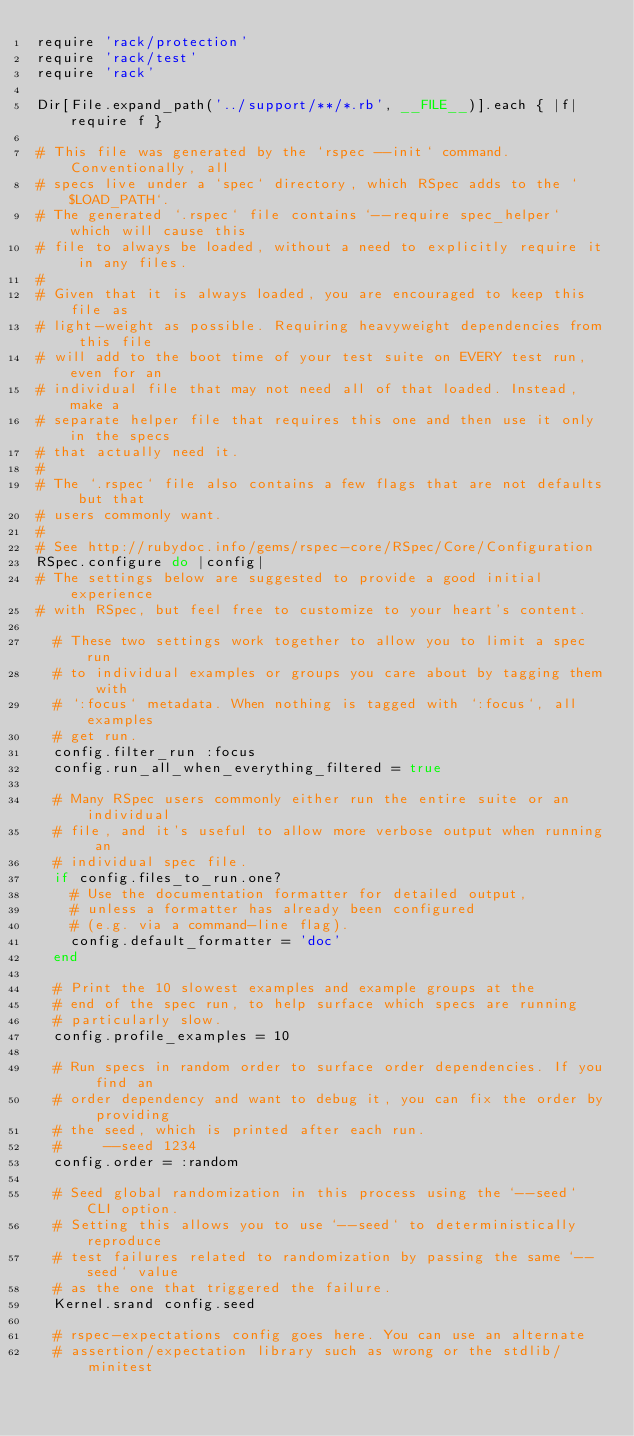Convert code to text. <code><loc_0><loc_0><loc_500><loc_500><_Ruby_>require 'rack/protection'
require 'rack/test'
require 'rack'

Dir[File.expand_path('../support/**/*.rb', __FILE__)].each { |f| require f }

# This file was generated by the `rspec --init` command. Conventionally, all
# specs live under a `spec` directory, which RSpec adds to the `$LOAD_PATH`.
# The generated `.rspec` file contains `--require spec_helper` which will cause this
# file to always be loaded, without a need to explicitly require it in any files.
#
# Given that it is always loaded, you are encouraged to keep this file as
# light-weight as possible. Requiring heavyweight dependencies from this file
# will add to the boot time of your test suite on EVERY test run, even for an
# individual file that may not need all of that loaded. Instead, make a
# separate helper file that requires this one and then use it only in the specs
# that actually need it.
#
# The `.rspec` file also contains a few flags that are not defaults but that
# users commonly want.
#
# See http://rubydoc.info/gems/rspec-core/RSpec/Core/Configuration
RSpec.configure do |config|
# The settings below are suggested to provide a good initial experience
# with RSpec, but feel free to customize to your heart's content.

  # These two settings work together to allow you to limit a spec run
  # to individual examples or groups you care about by tagging them with
  # `:focus` metadata. When nothing is tagged with `:focus`, all examples
  # get run.
  config.filter_run :focus
  config.run_all_when_everything_filtered = true

  # Many RSpec users commonly either run the entire suite or an individual
  # file, and it's useful to allow more verbose output when running an
  # individual spec file.
  if config.files_to_run.one?
    # Use the documentation formatter for detailed output,
    # unless a formatter has already been configured
    # (e.g. via a command-line flag).
    config.default_formatter = 'doc'
  end

  # Print the 10 slowest examples and example groups at the
  # end of the spec run, to help surface which specs are running
  # particularly slow.
  config.profile_examples = 10

  # Run specs in random order to surface order dependencies. If you find an
  # order dependency and want to debug it, you can fix the order by providing
  # the seed, which is printed after each run.
  #     --seed 1234
  config.order = :random

  # Seed global randomization in this process using the `--seed` CLI option.
  # Setting this allows you to use `--seed` to deterministically reproduce
  # test failures related to randomization by passing the same `--seed` value
  # as the one that triggered the failure.
  Kernel.srand config.seed

  # rspec-expectations config goes here. You can use an alternate
  # assertion/expectation library such as wrong or the stdlib/minitest</code> 